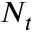Convert formula to latex. <formula><loc_0><loc_0><loc_500><loc_500>N _ { t }</formula> 